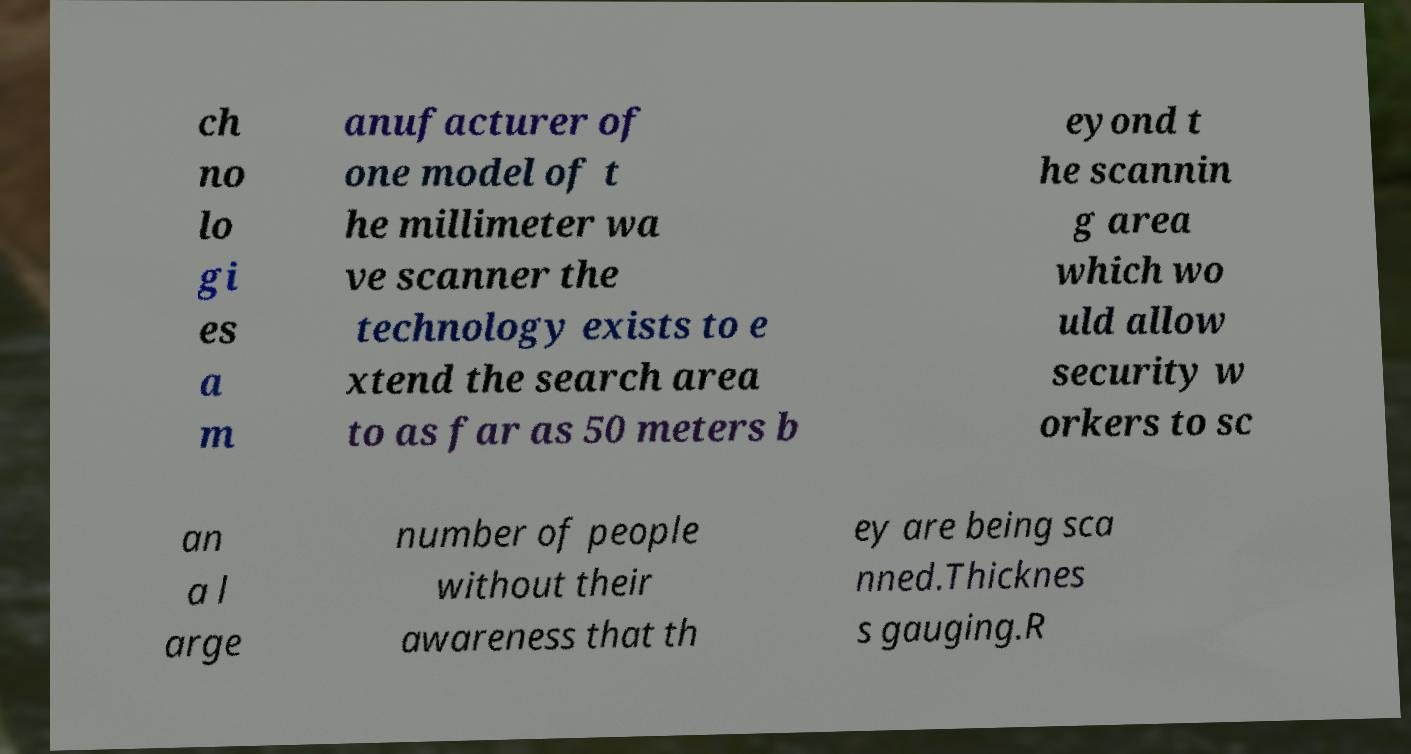There's text embedded in this image that I need extracted. Can you transcribe it verbatim? ch no lo gi es a m anufacturer of one model of t he millimeter wa ve scanner the technology exists to e xtend the search area to as far as 50 meters b eyond t he scannin g area which wo uld allow security w orkers to sc an a l arge number of people without their awareness that th ey are being sca nned.Thicknes s gauging.R 